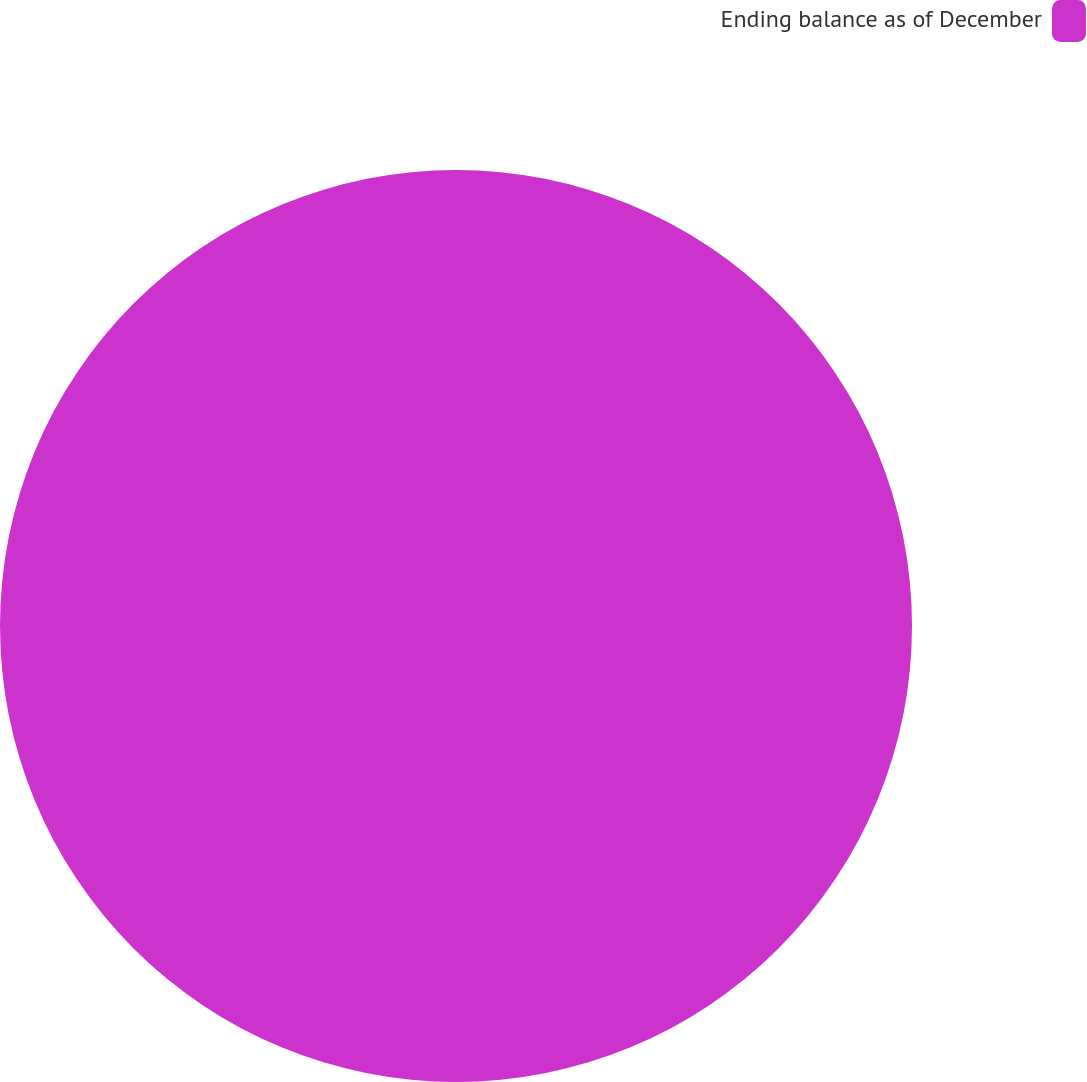Convert chart. <chart><loc_0><loc_0><loc_500><loc_500><pie_chart><fcel>Ending balance as of December<nl><fcel>100.0%<nl></chart> 